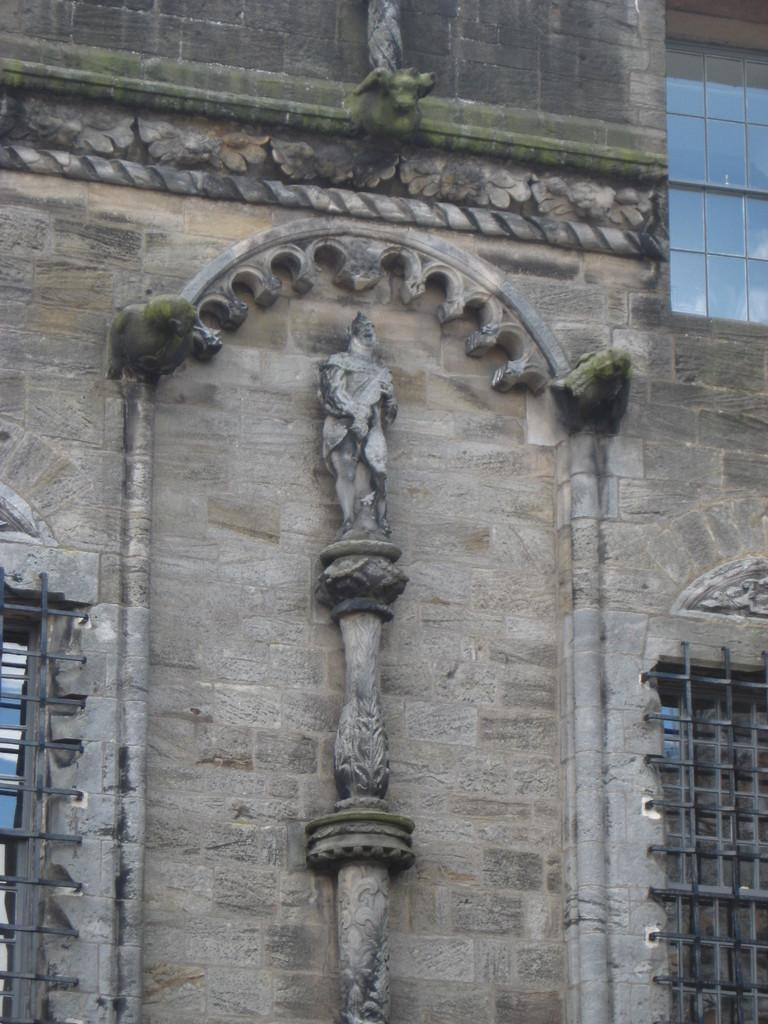What is the main subject in the center of the image? There is a building in the center of the image. What decorative elements can be seen on the building? There are sculptures on the building. Where are the windows located in the image? The windows are on the right side of the image. What type of mice can be seen climbing the building in the image? There are no mice present in the image; it features a building with sculptures and windows. What is the title of the sculpture on the building? The provided facts do not mention a title for the sculpture, so we cannot determine its title from the image. 